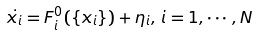Convert formula to latex. <formula><loc_0><loc_0><loc_500><loc_500>\dot { x _ { i } } = F _ { i } ^ { 0 } ( \{ x _ { i } \} ) + \eta _ { i } , \, i = 1 , \cdots , N</formula> 